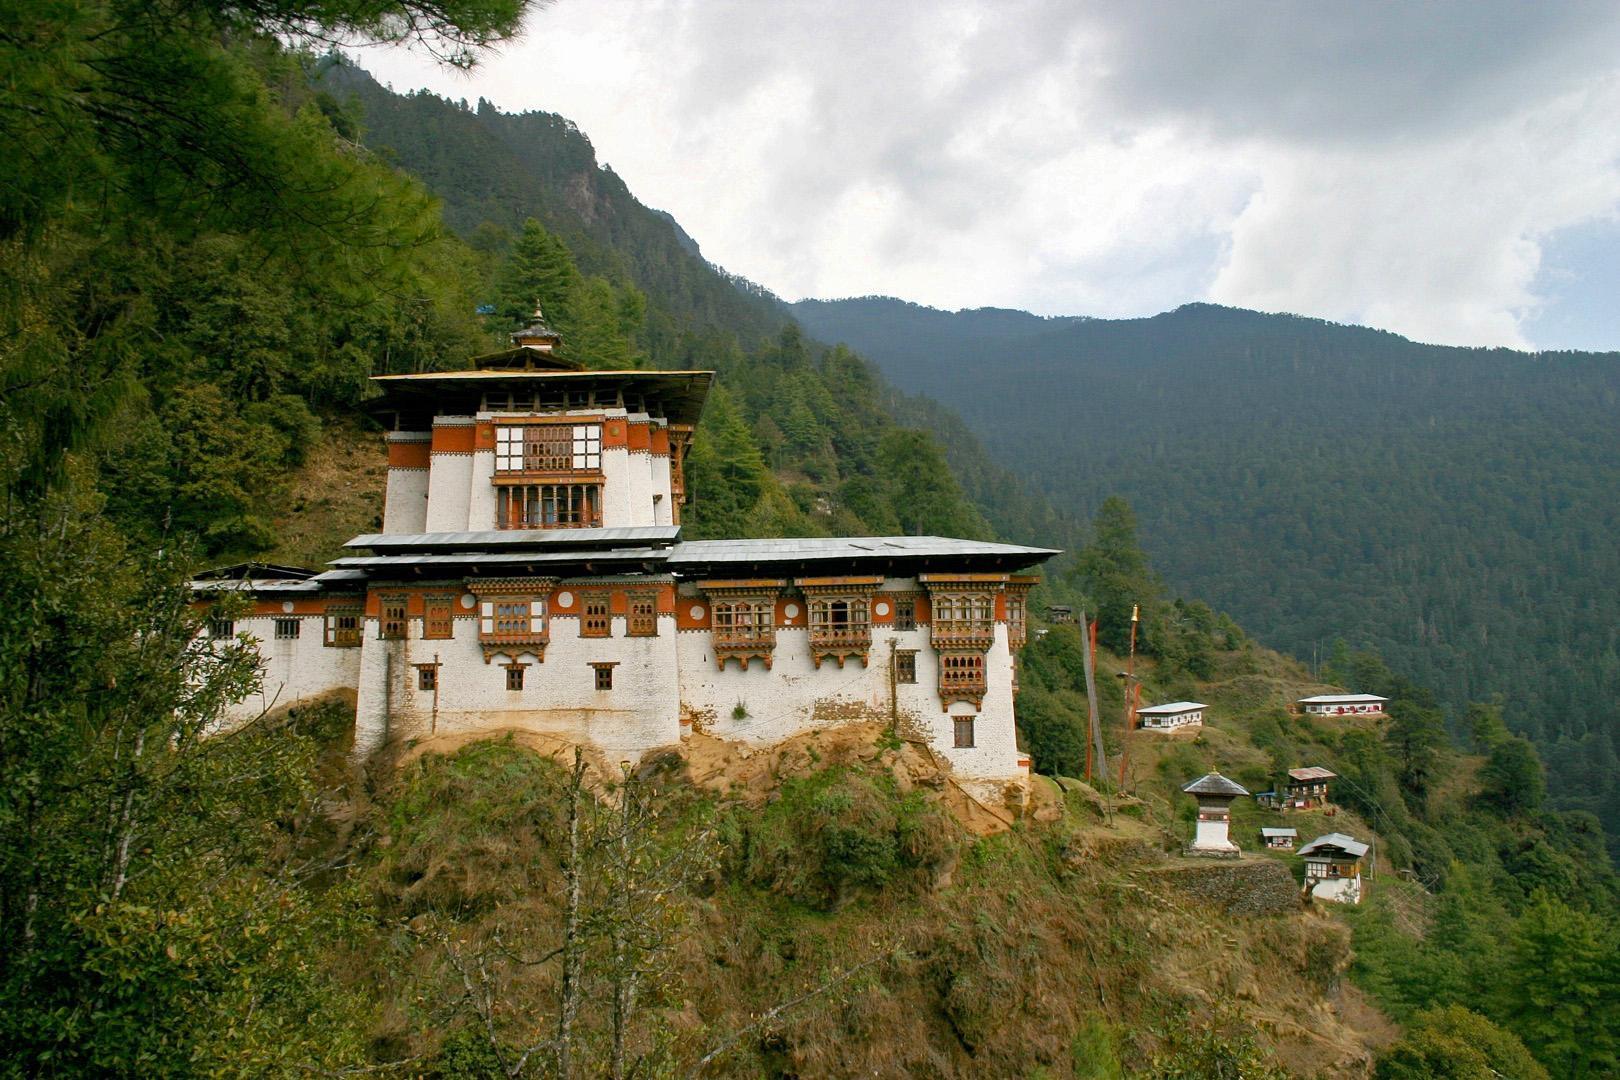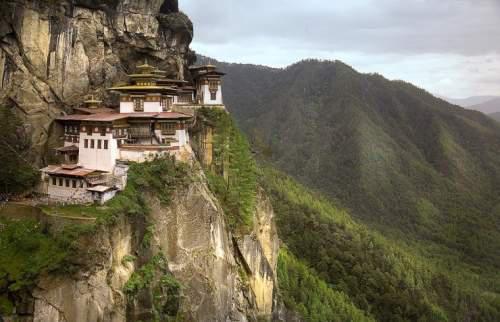The first image is the image on the left, the second image is the image on the right. Considering the images on both sides, is "In one of the images there is more than one person." valid? Answer yes or no. No. The first image is the image on the left, the second image is the image on the right. Analyze the images presented: Is the assertion "An image shows multiple people in front of a hillside building." valid? Answer yes or no. No. 